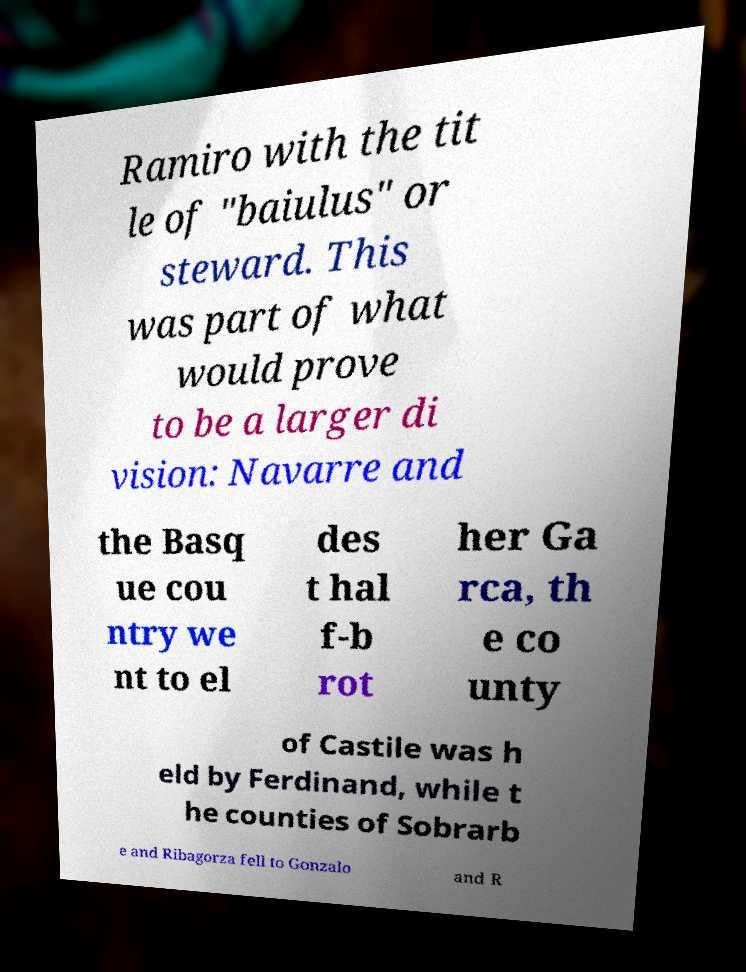I need the written content from this picture converted into text. Can you do that? Ramiro with the tit le of "baiulus" or steward. This was part of what would prove to be a larger di vision: Navarre and the Basq ue cou ntry we nt to el des t hal f-b rot her Ga rca, th e co unty of Castile was h eld by Ferdinand, while t he counties of Sobrarb e and Ribagorza fell to Gonzalo and R 